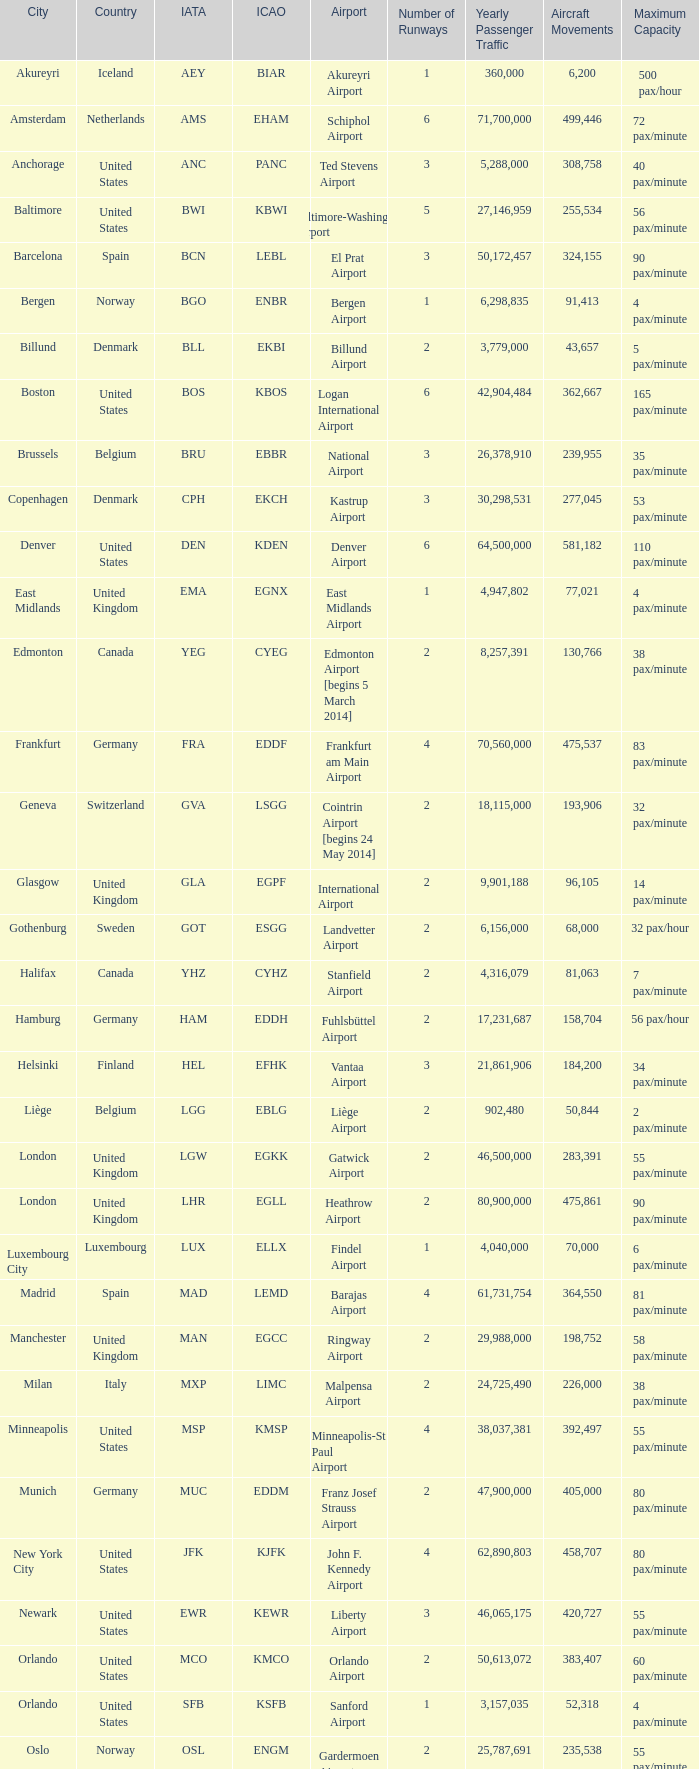What is the Airport with a ICAO of EDDH? Fuhlsbüttel Airport. 